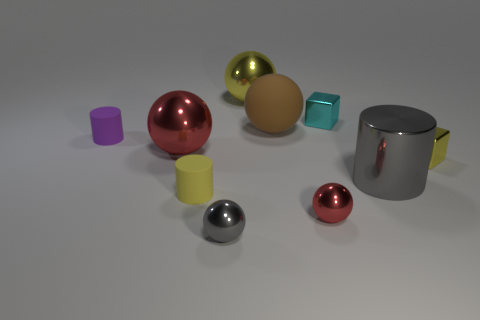Subtract all brown rubber spheres. How many spheres are left? 4 Subtract 2 balls. How many balls are left? 3 Subtract all red blocks. How many red balls are left? 2 Subtract all yellow spheres. How many spheres are left? 4 Subtract all cylinders. How many objects are left? 7 Subtract all green cylinders. Subtract all yellow cubes. How many cylinders are left? 3 Add 8 large rubber balls. How many large rubber balls are left? 9 Add 8 brown matte spheres. How many brown matte spheres exist? 9 Subtract 0 blue cylinders. How many objects are left? 10 Subtract all tiny balls. Subtract all shiny cylinders. How many objects are left? 7 